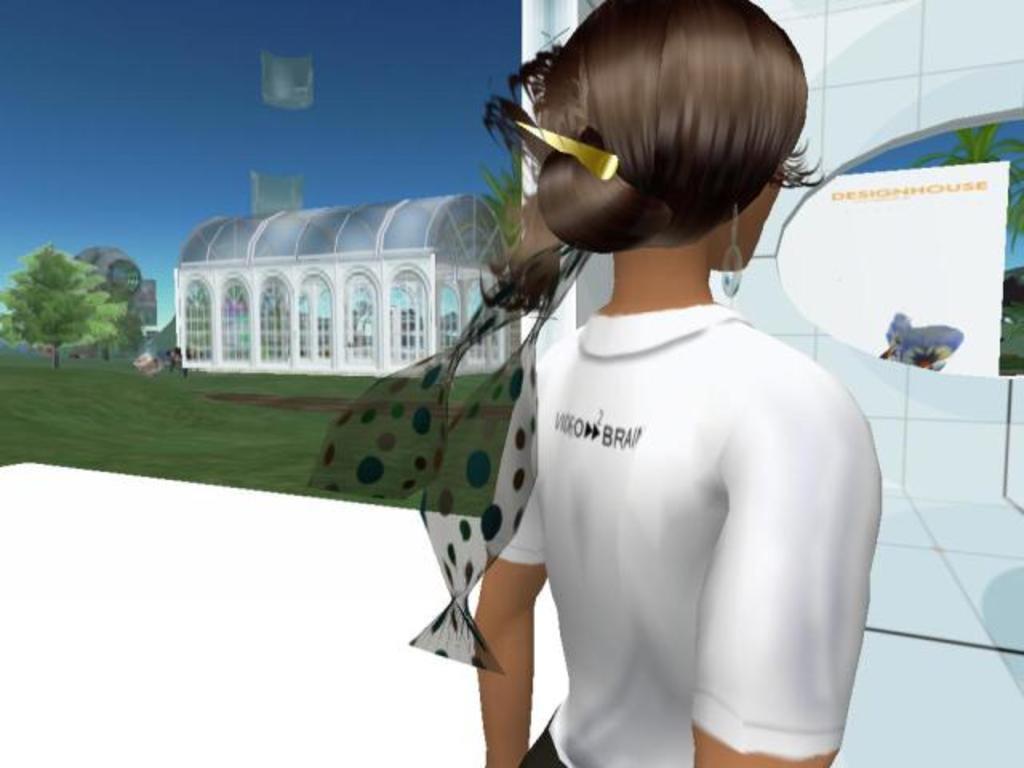How would you summarize this image in a sentence or two? This is a graphical picture and in this picture we can see a person, house, trees, grass, some objects and the sky. 